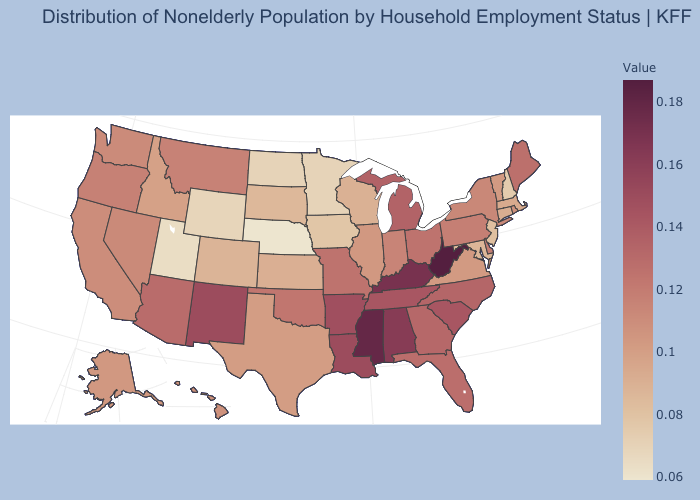Does West Virginia have the highest value in the USA?
Write a very short answer. Yes. Does Michigan have a lower value than Kentucky?
Quick response, please. Yes. Does Utah have the lowest value in the West?
Quick response, please. Yes. Does West Virginia have the highest value in the USA?
Keep it brief. Yes. Which states hav the highest value in the MidWest?
Keep it brief. Michigan. 